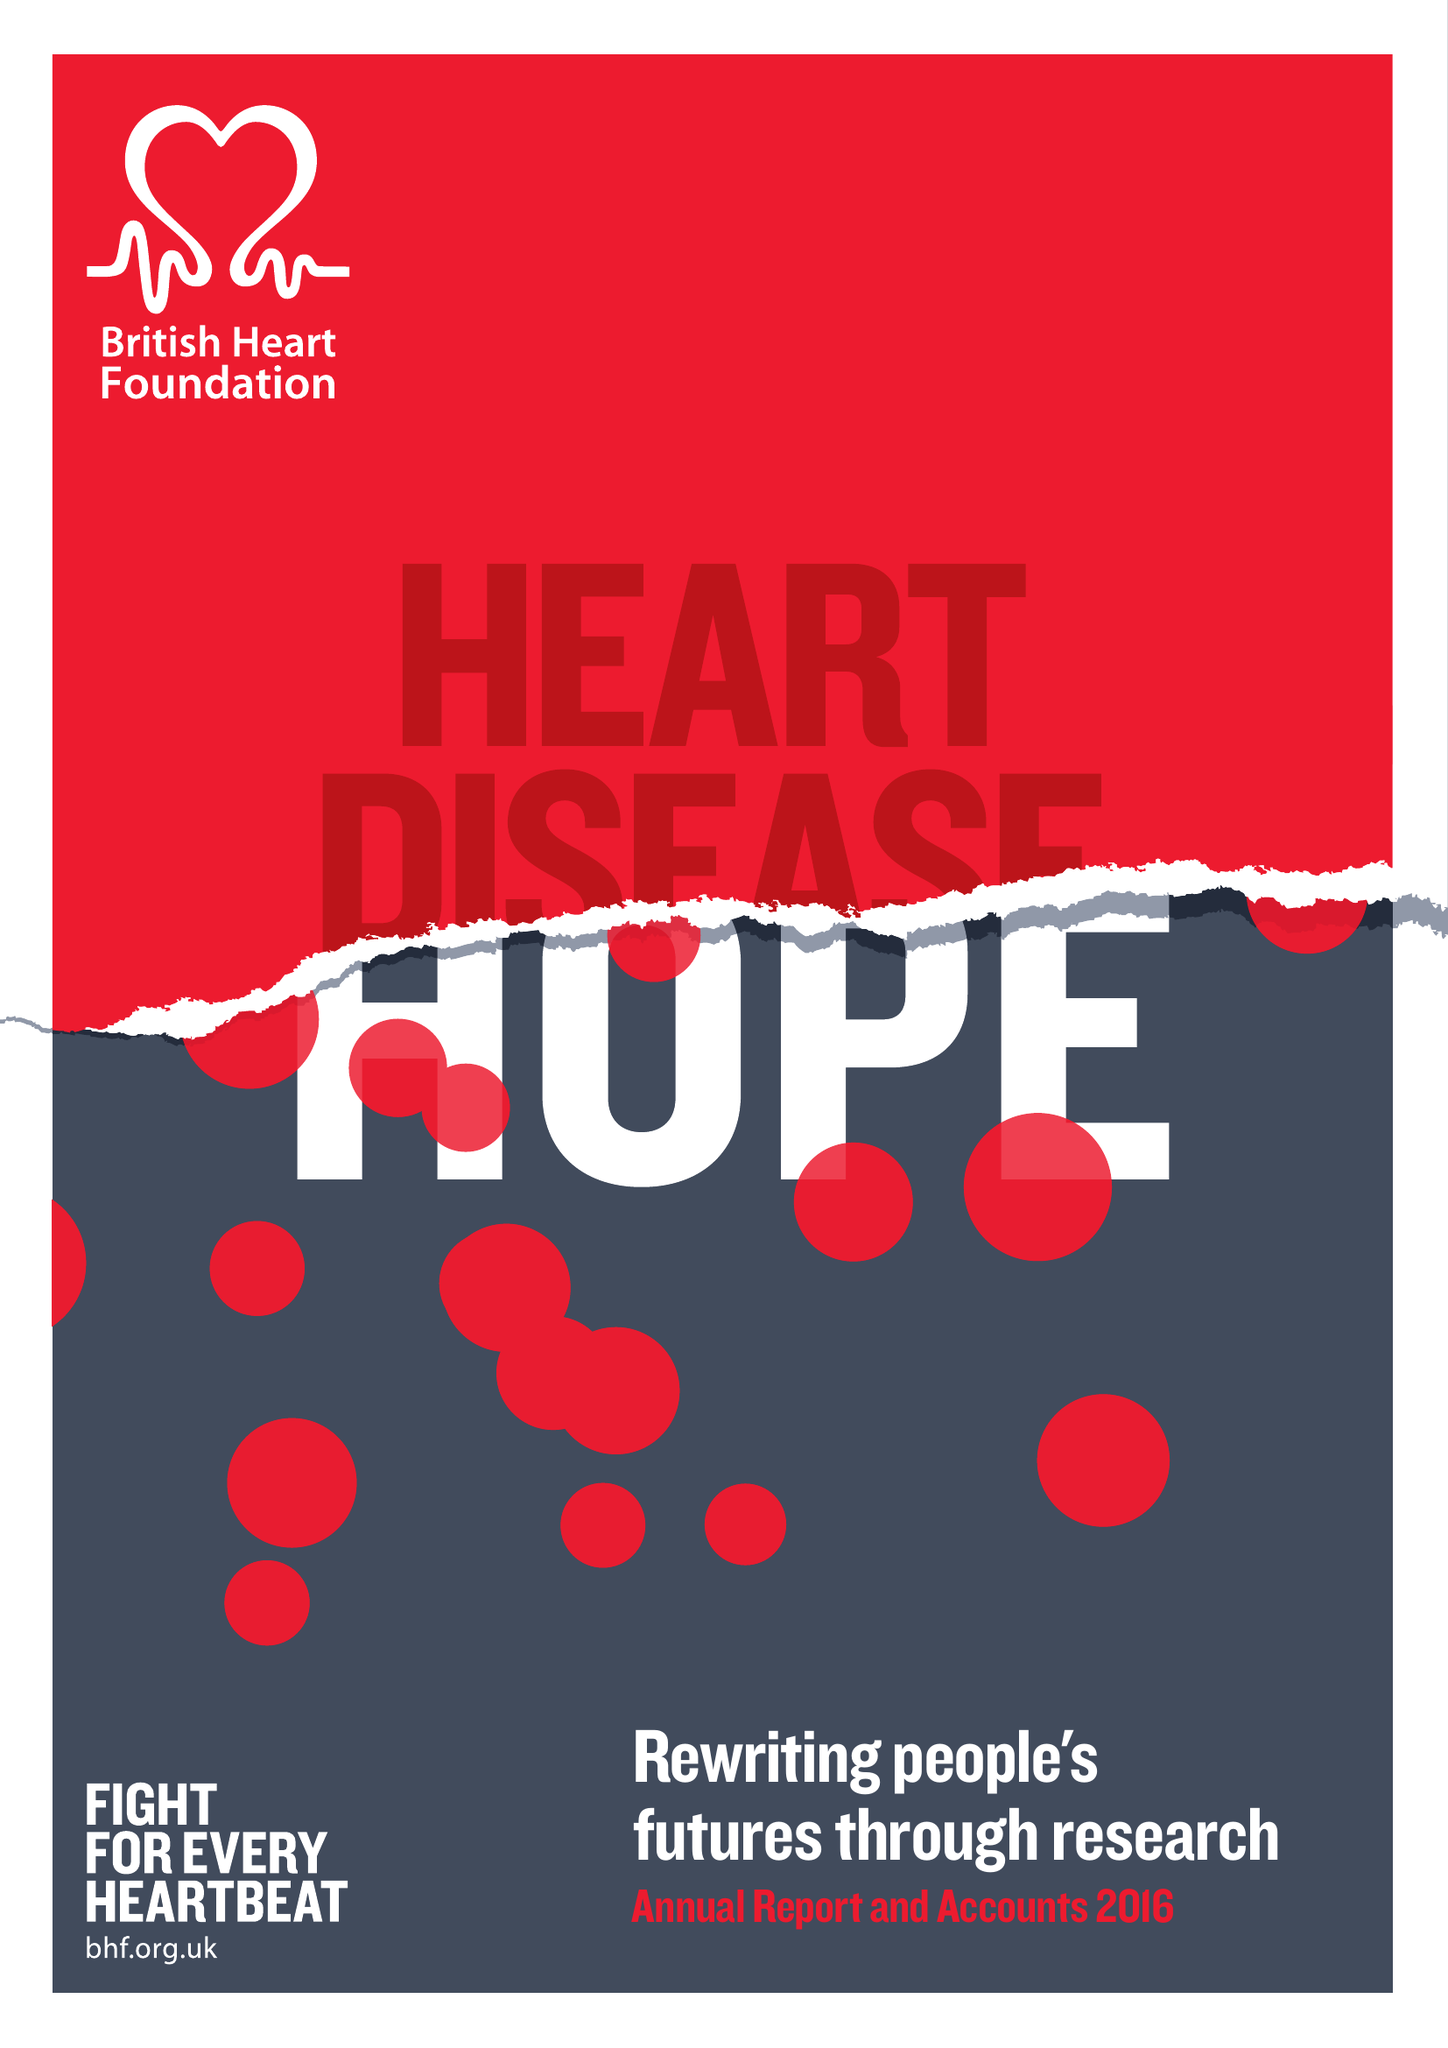What is the value for the address__post_town?
Answer the question using a single word or phrase. LONDON 